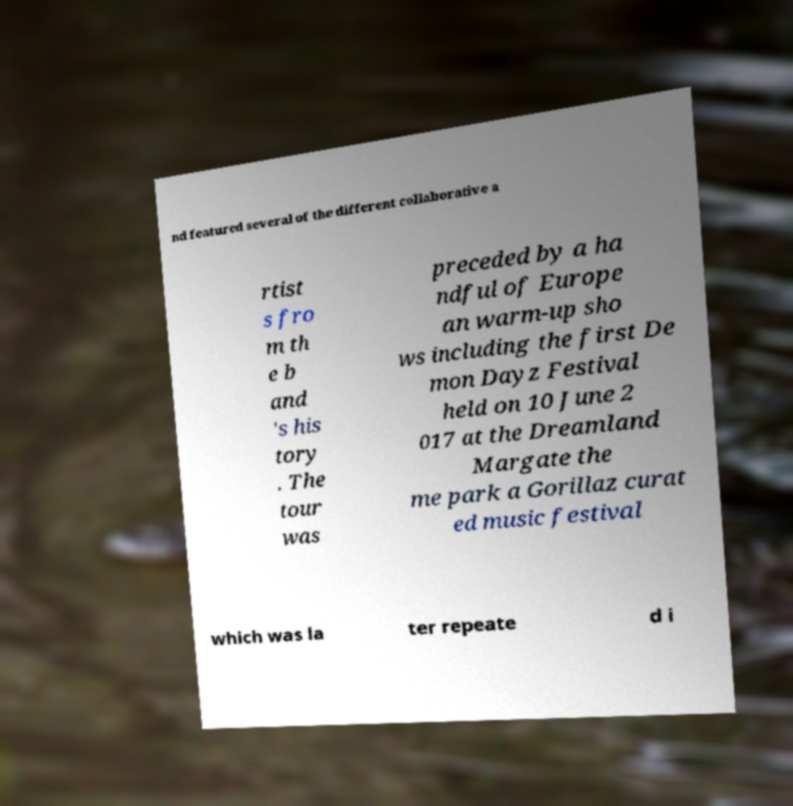Can you read and provide the text displayed in the image?This photo seems to have some interesting text. Can you extract and type it out for me? nd featured several of the different collaborative a rtist s fro m th e b and 's his tory . The tour was preceded by a ha ndful of Europe an warm-up sho ws including the first De mon Dayz Festival held on 10 June 2 017 at the Dreamland Margate the me park a Gorillaz curat ed music festival which was la ter repeate d i 